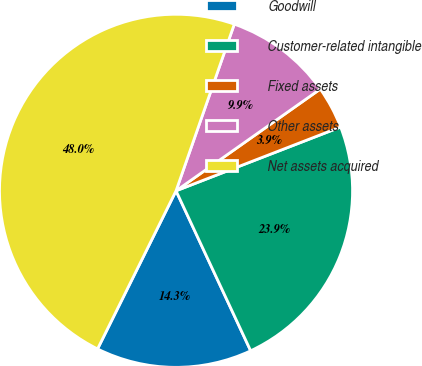Convert chart to OTSL. <chart><loc_0><loc_0><loc_500><loc_500><pie_chart><fcel>Goodwill<fcel>Customer-related intangible<fcel>Fixed assets<fcel>Other assets<fcel>Net assets acquired<nl><fcel>14.28%<fcel>23.94%<fcel>3.89%<fcel>9.87%<fcel>48.02%<nl></chart> 